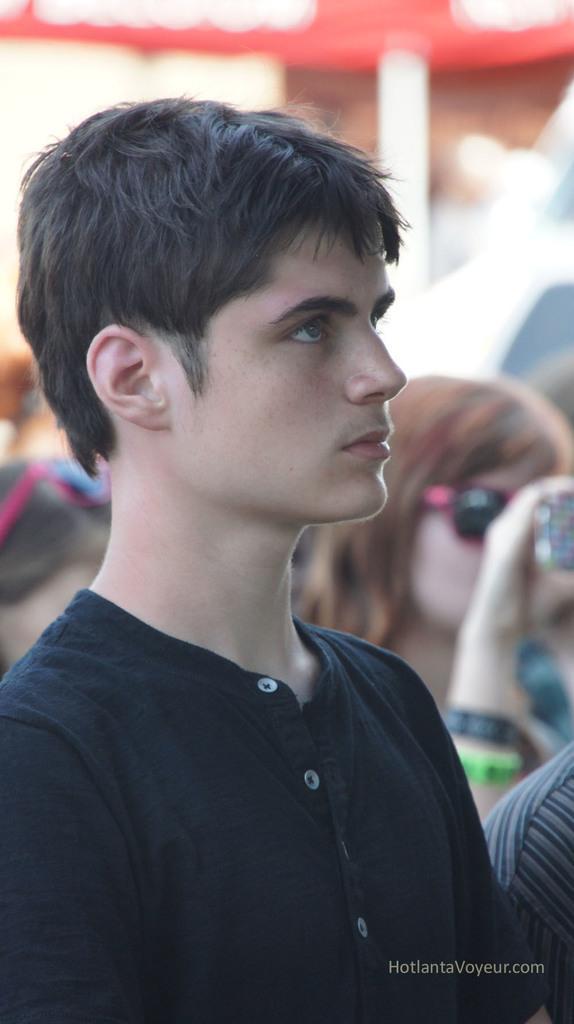Can you describe this image briefly? In this image I can see people among them this man is wearing black color clothes. The background of the image is blurred. Here I can see a watermark. 